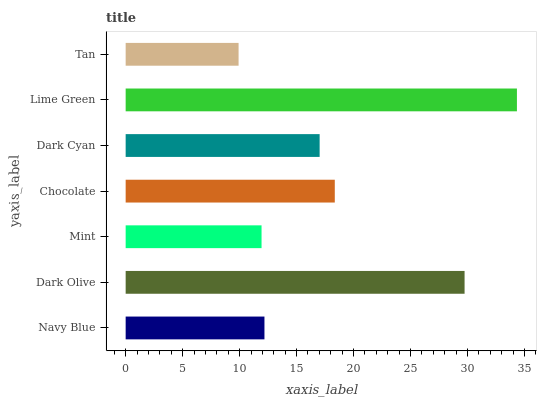Is Tan the minimum?
Answer yes or no. Yes. Is Lime Green the maximum?
Answer yes or no. Yes. Is Dark Olive the minimum?
Answer yes or no. No. Is Dark Olive the maximum?
Answer yes or no. No. Is Dark Olive greater than Navy Blue?
Answer yes or no. Yes. Is Navy Blue less than Dark Olive?
Answer yes or no. Yes. Is Navy Blue greater than Dark Olive?
Answer yes or no. No. Is Dark Olive less than Navy Blue?
Answer yes or no. No. Is Dark Cyan the high median?
Answer yes or no. Yes. Is Dark Cyan the low median?
Answer yes or no. Yes. Is Tan the high median?
Answer yes or no. No. Is Chocolate the low median?
Answer yes or no. No. 